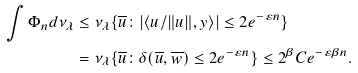<formula> <loc_0><loc_0><loc_500><loc_500>\int \Phi _ { n } d \nu _ { \lambda } & \leq \nu _ { \lambda } \{ \overline { u } \colon | \langle u / \| u \| , y \rangle | \leq 2 e ^ { - \varepsilon n } \} \\ & = \nu _ { \lambda } \{ \overline { u } \colon \delta ( \overline { u } , \overline { w } ) \leq 2 e ^ { - \varepsilon n } \} \leq 2 ^ { \beta } C e ^ { - \varepsilon \beta n } .</formula> 